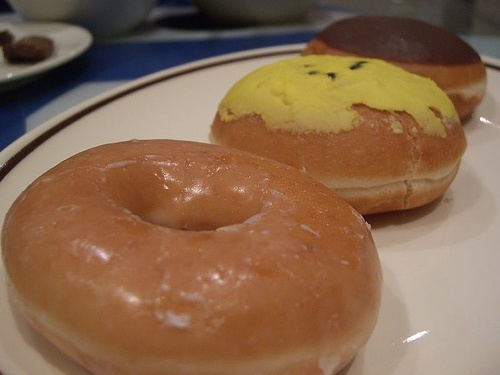Describe the objects in this image and their specific colors. I can see donut in black, brown, and tan tones, donut in black, brown, tan, gray, and olive tones, and donut in black, maroon, and brown tones in this image. 